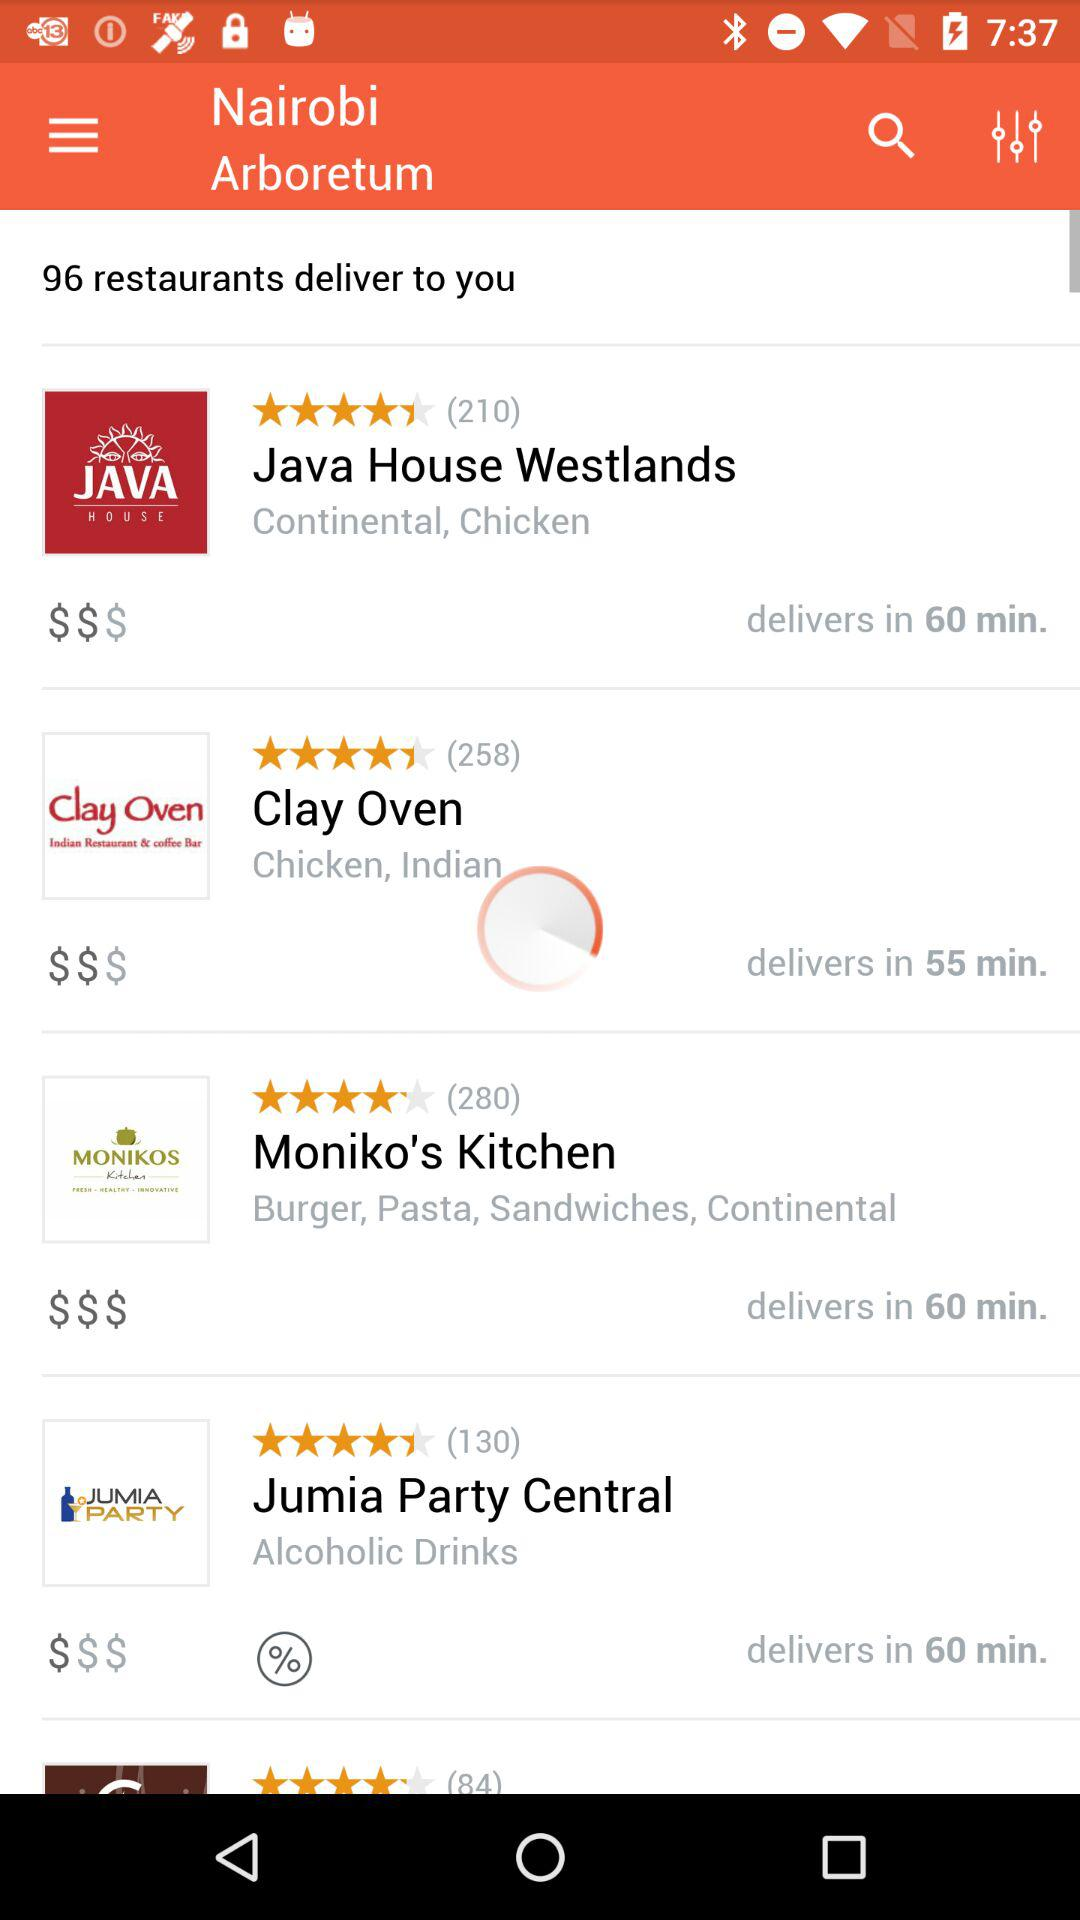In how much time will Moniko's Kitchen deliver? Moniko's Kitchen will deliver in 60 minutes. 